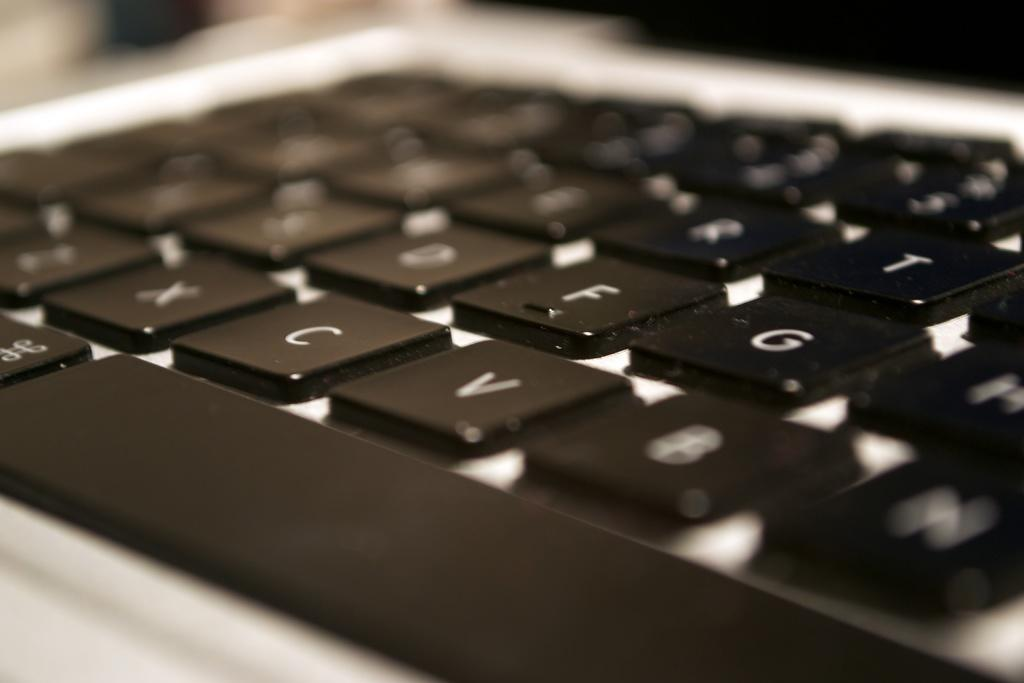<image>
Write a terse but informative summary of the picture. C and V keys are highlighted on this standard keyboard. 